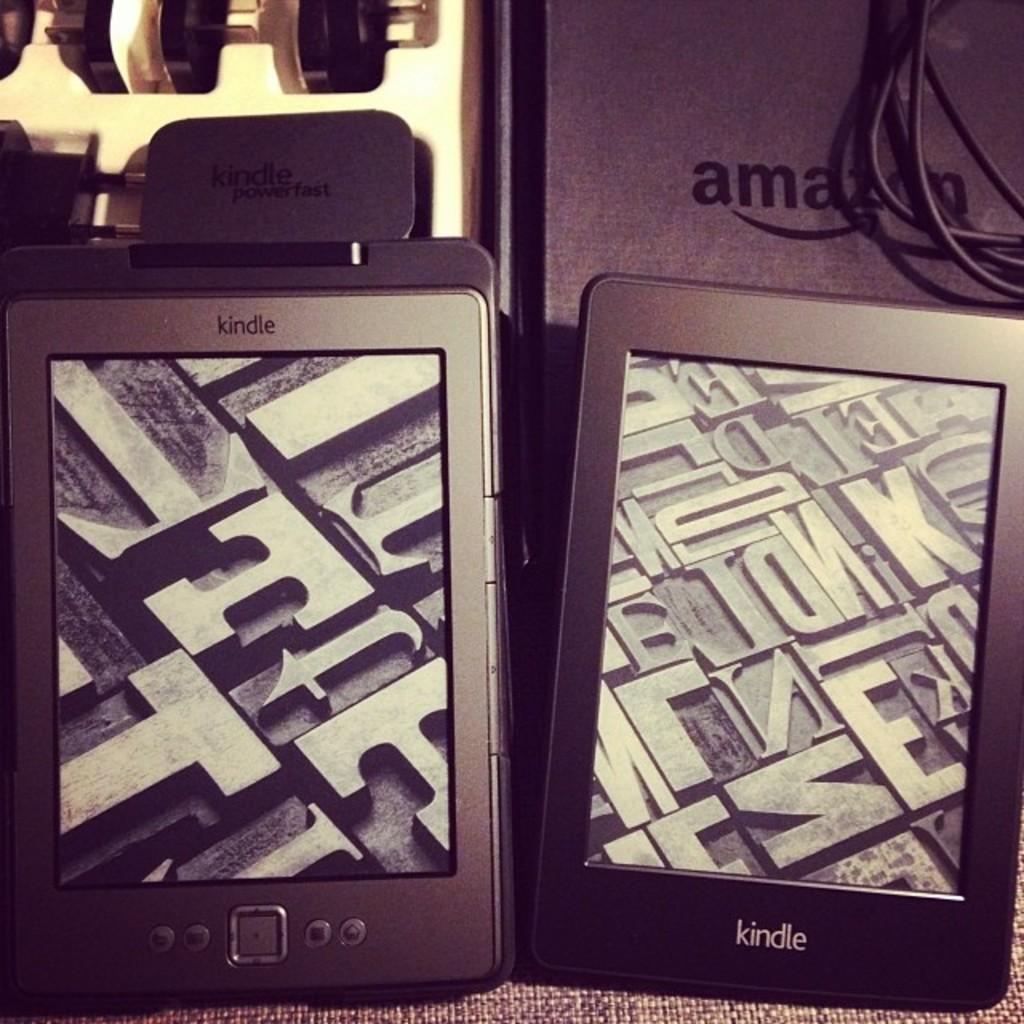<image>
Relay a brief, clear account of the picture shown. a screen that has the word kindle at the bottom 